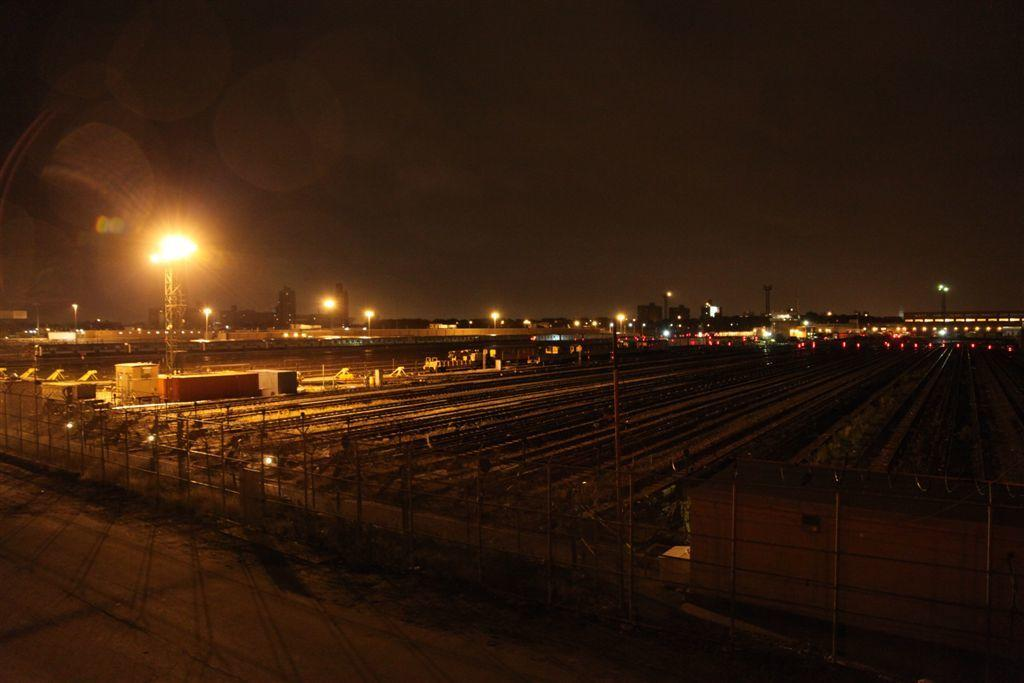What can be seen in the foreground of the image? There is a fencing and a road in the foreground of the image. What is visible in the background of the image? There are poles, lights, and buildings in the background of the image. Additionally, the sky is dark in the background. Can you describe the lighting conditions in the image? The lights in the background suggest that it might be nighttime or that there is artificial lighting present. How many beds can be seen in the image? There are no beds present in the image. What type of action is being performed by the achiever in the image? There is no achiever or action being performed in the image. 